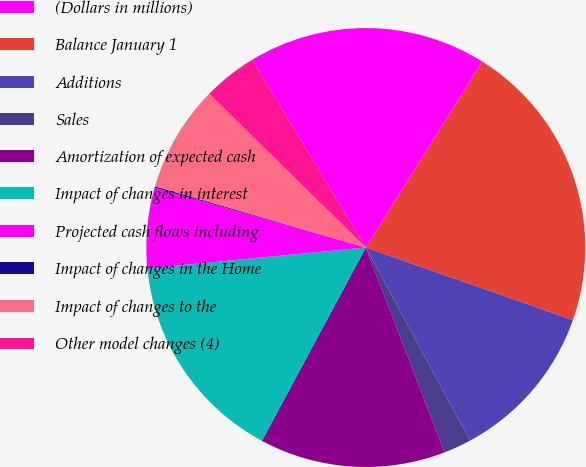<chart> <loc_0><loc_0><loc_500><loc_500><pie_chart><fcel>(Dollars in millions)<fcel>Balance January 1<fcel>Additions<fcel>Sales<fcel>Amortization of expected cash<fcel>Impact of changes in interest<fcel>Projected cash flows including<fcel>Impact of changes in the Home<fcel>Impact of changes to the<fcel>Other model changes (4)<nl><fcel>17.57%<fcel>21.46%<fcel>11.75%<fcel>2.04%<fcel>13.69%<fcel>15.63%<fcel>5.92%<fcel>0.1%<fcel>7.86%<fcel>3.98%<nl></chart> 